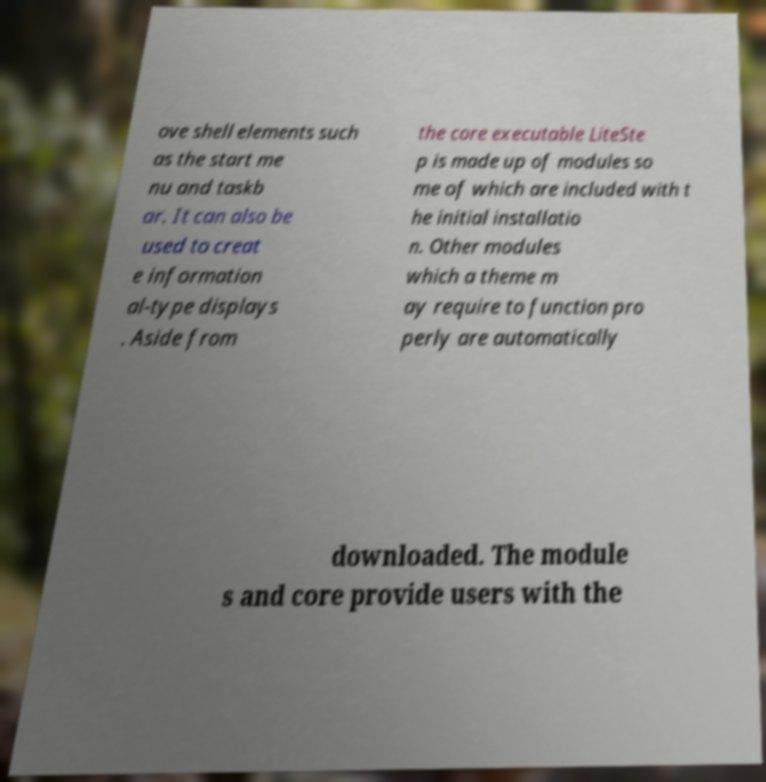There's text embedded in this image that I need extracted. Can you transcribe it verbatim? ove shell elements such as the start me nu and taskb ar. It can also be used to creat e information al-type displays . Aside from the core executable LiteSte p is made up of modules so me of which are included with t he initial installatio n. Other modules which a theme m ay require to function pro perly are automatically downloaded. The module s and core provide users with the 